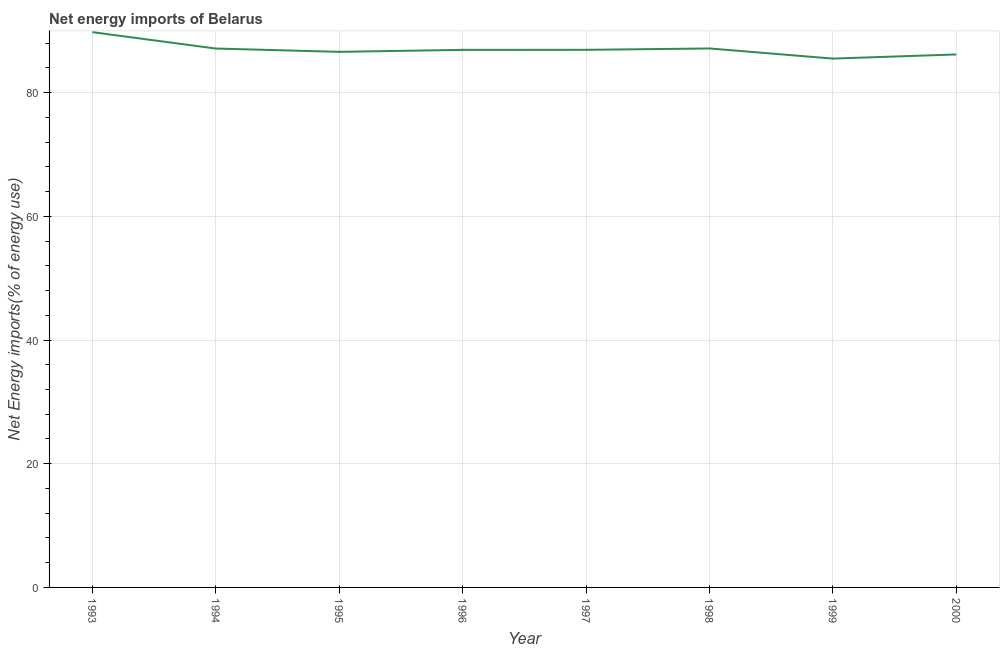What is the energy imports in 1997?
Offer a terse response. 86.92. Across all years, what is the maximum energy imports?
Offer a terse response. 89.77. Across all years, what is the minimum energy imports?
Your answer should be compact. 85.5. In which year was the energy imports maximum?
Ensure brevity in your answer.  1993. In which year was the energy imports minimum?
Give a very brief answer. 1999. What is the sum of the energy imports?
Give a very brief answer. 696.11. What is the difference between the energy imports in 1995 and 1998?
Ensure brevity in your answer.  -0.55. What is the average energy imports per year?
Provide a short and direct response. 87.01. What is the median energy imports?
Your response must be concise. 86.91. In how many years, is the energy imports greater than 76 %?
Your answer should be very brief. 8. Do a majority of the years between 1998 and 1994 (inclusive) have energy imports greater than 36 %?
Make the answer very short. Yes. What is the ratio of the energy imports in 1995 to that in 1998?
Ensure brevity in your answer.  0.99. What is the difference between the highest and the second highest energy imports?
Your response must be concise. 2.64. Is the sum of the energy imports in 1995 and 1999 greater than the maximum energy imports across all years?
Provide a succinct answer. Yes. What is the difference between the highest and the lowest energy imports?
Make the answer very short. 4.27. In how many years, is the energy imports greater than the average energy imports taken over all years?
Provide a short and direct response. 3. Does the energy imports monotonically increase over the years?
Provide a succinct answer. No. How many lines are there?
Offer a terse response. 1. What is the difference between two consecutive major ticks on the Y-axis?
Make the answer very short. 20. Does the graph contain any zero values?
Ensure brevity in your answer.  No. Does the graph contain grids?
Keep it short and to the point. Yes. What is the title of the graph?
Your answer should be very brief. Net energy imports of Belarus. What is the label or title of the X-axis?
Provide a succinct answer. Year. What is the label or title of the Y-axis?
Give a very brief answer. Net Energy imports(% of energy use). What is the Net Energy imports(% of energy use) of 1993?
Offer a terse response. 89.77. What is the Net Energy imports(% of energy use) of 1994?
Your answer should be compact. 87.12. What is the Net Energy imports(% of energy use) of 1995?
Give a very brief answer. 86.59. What is the Net Energy imports(% of energy use) in 1996?
Offer a terse response. 86.91. What is the Net Energy imports(% of energy use) of 1997?
Give a very brief answer. 86.92. What is the Net Energy imports(% of energy use) of 1998?
Your answer should be very brief. 87.14. What is the Net Energy imports(% of energy use) of 1999?
Your response must be concise. 85.5. What is the Net Energy imports(% of energy use) in 2000?
Ensure brevity in your answer.  86.17. What is the difference between the Net Energy imports(% of energy use) in 1993 and 1994?
Keep it short and to the point. 2.65. What is the difference between the Net Energy imports(% of energy use) in 1993 and 1995?
Offer a terse response. 3.18. What is the difference between the Net Energy imports(% of energy use) in 1993 and 1996?
Offer a terse response. 2.86. What is the difference between the Net Energy imports(% of energy use) in 1993 and 1997?
Offer a terse response. 2.86. What is the difference between the Net Energy imports(% of energy use) in 1993 and 1998?
Give a very brief answer. 2.64. What is the difference between the Net Energy imports(% of energy use) in 1993 and 1999?
Your response must be concise. 4.27. What is the difference between the Net Energy imports(% of energy use) in 1993 and 2000?
Provide a succinct answer. 3.61. What is the difference between the Net Energy imports(% of energy use) in 1994 and 1995?
Offer a very short reply. 0.53. What is the difference between the Net Energy imports(% of energy use) in 1994 and 1996?
Provide a succinct answer. 0.21. What is the difference between the Net Energy imports(% of energy use) in 1994 and 1997?
Keep it short and to the point. 0.21. What is the difference between the Net Energy imports(% of energy use) in 1994 and 1998?
Your answer should be very brief. -0.01. What is the difference between the Net Energy imports(% of energy use) in 1994 and 1999?
Your answer should be compact. 1.62. What is the difference between the Net Energy imports(% of energy use) in 1994 and 2000?
Provide a short and direct response. 0.96. What is the difference between the Net Energy imports(% of energy use) in 1995 and 1996?
Offer a terse response. -0.32. What is the difference between the Net Energy imports(% of energy use) in 1995 and 1997?
Your answer should be compact. -0.33. What is the difference between the Net Energy imports(% of energy use) in 1995 and 1998?
Your answer should be compact. -0.55. What is the difference between the Net Energy imports(% of energy use) in 1995 and 1999?
Offer a very short reply. 1.09. What is the difference between the Net Energy imports(% of energy use) in 1995 and 2000?
Provide a succinct answer. 0.42. What is the difference between the Net Energy imports(% of energy use) in 1996 and 1997?
Give a very brief answer. -0. What is the difference between the Net Energy imports(% of energy use) in 1996 and 1998?
Keep it short and to the point. -0.22. What is the difference between the Net Energy imports(% of energy use) in 1996 and 1999?
Offer a very short reply. 1.41. What is the difference between the Net Energy imports(% of energy use) in 1996 and 2000?
Offer a very short reply. 0.74. What is the difference between the Net Energy imports(% of energy use) in 1997 and 1998?
Your answer should be compact. -0.22. What is the difference between the Net Energy imports(% of energy use) in 1997 and 1999?
Make the answer very short. 1.42. What is the difference between the Net Energy imports(% of energy use) in 1997 and 2000?
Provide a succinct answer. 0.75. What is the difference between the Net Energy imports(% of energy use) in 1998 and 1999?
Offer a terse response. 1.64. What is the difference between the Net Energy imports(% of energy use) in 1998 and 2000?
Offer a very short reply. 0.97. What is the difference between the Net Energy imports(% of energy use) in 1999 and 2000?
Your answer should be compact. -0.67. What is the ratio of the Net Energy imports(% of energy use) in 1993 to that in 1994?
Ensure brevity in your answer.  1.03. What is the ratio of the Net Energy imports(% of energy use) in 1993 to that in 1996?
Offer a terse response. 1.03. What is the ratio of the Net Energy imports(% of energy use) in 1993 to that in 1997?
Make the answer very short. 1.03. What is the ratio of the Net Energy imports(% of energy use) in 1993 to that in 1998?
Give a very brief answer. 1.03. What is the ratio of the Net Energy imports(% of energy use) in 1993 to that in 2000?
Your answer should be compact. 1.04. What is the ratio of the Net Energy imports(% of energy use) in 1994 to that in 1995?
Your response must be concise. 1.01. What is the ratio of the Net Energy imports(% of energy use) in 1994 to that in 1997?
Give a very brief answer. 1. What is the ratio of the Net Energy imports(% of energy use) in 1994 to that in 1999?
Your answer should be very brief. 1.02. What is the ratio of the Net Energy imports(% of energy use) in 1995 to that in 1996?
Keep it short and to the point. 1. What is the ratio of the Net Energy imports(% of energy use) in 1995 to that in 1998?
Make the answer very short. 0.99. What is the ratio of the Net Energy imports(% of energy use) in 1996 to that in 1997?
Your answer should be compact. 1. What is the ratio of the Net Energy imports(% of energy use) in 1996 to that in 1998?
Offer a terse response. 1. What is the ratio of the Net Energy imports(% of energy use) in 1996 to that in 1999?
Provide a succinct answer. 1.02. What is the ratio of the Net Energy imports(% of energy use) in 1998 to that in 1999?
Provide a short and direct response. 1.02. What is the ratio of the Net Energy imports(% of energy use) in 1999 to that in 2000?
Make the answer very short. 0.99. 